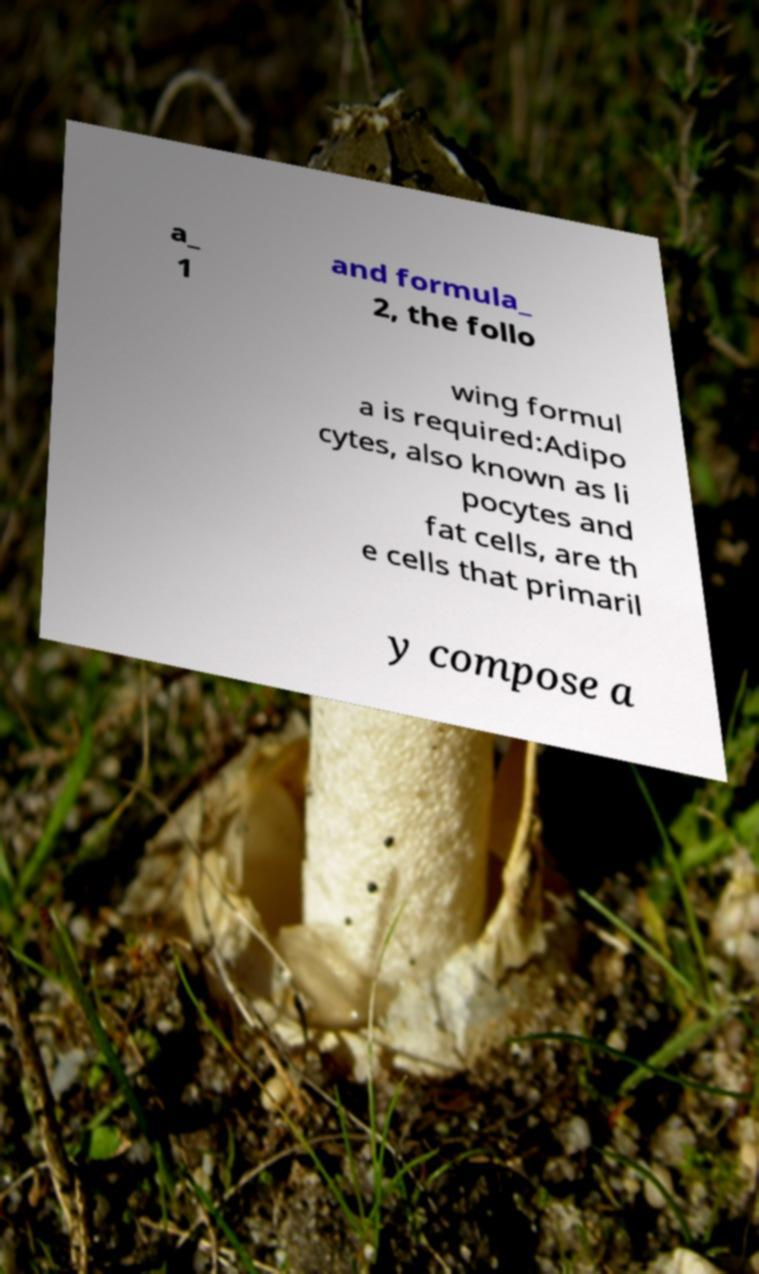For documentation purposes, I need the text within this image transcribed. Could you provide that? a_ 1 and formula_ 2, the follo wing formul a is required:Adipo cytes, also known as li pocytes and fat cells, are th e cells that primaril y compose a 